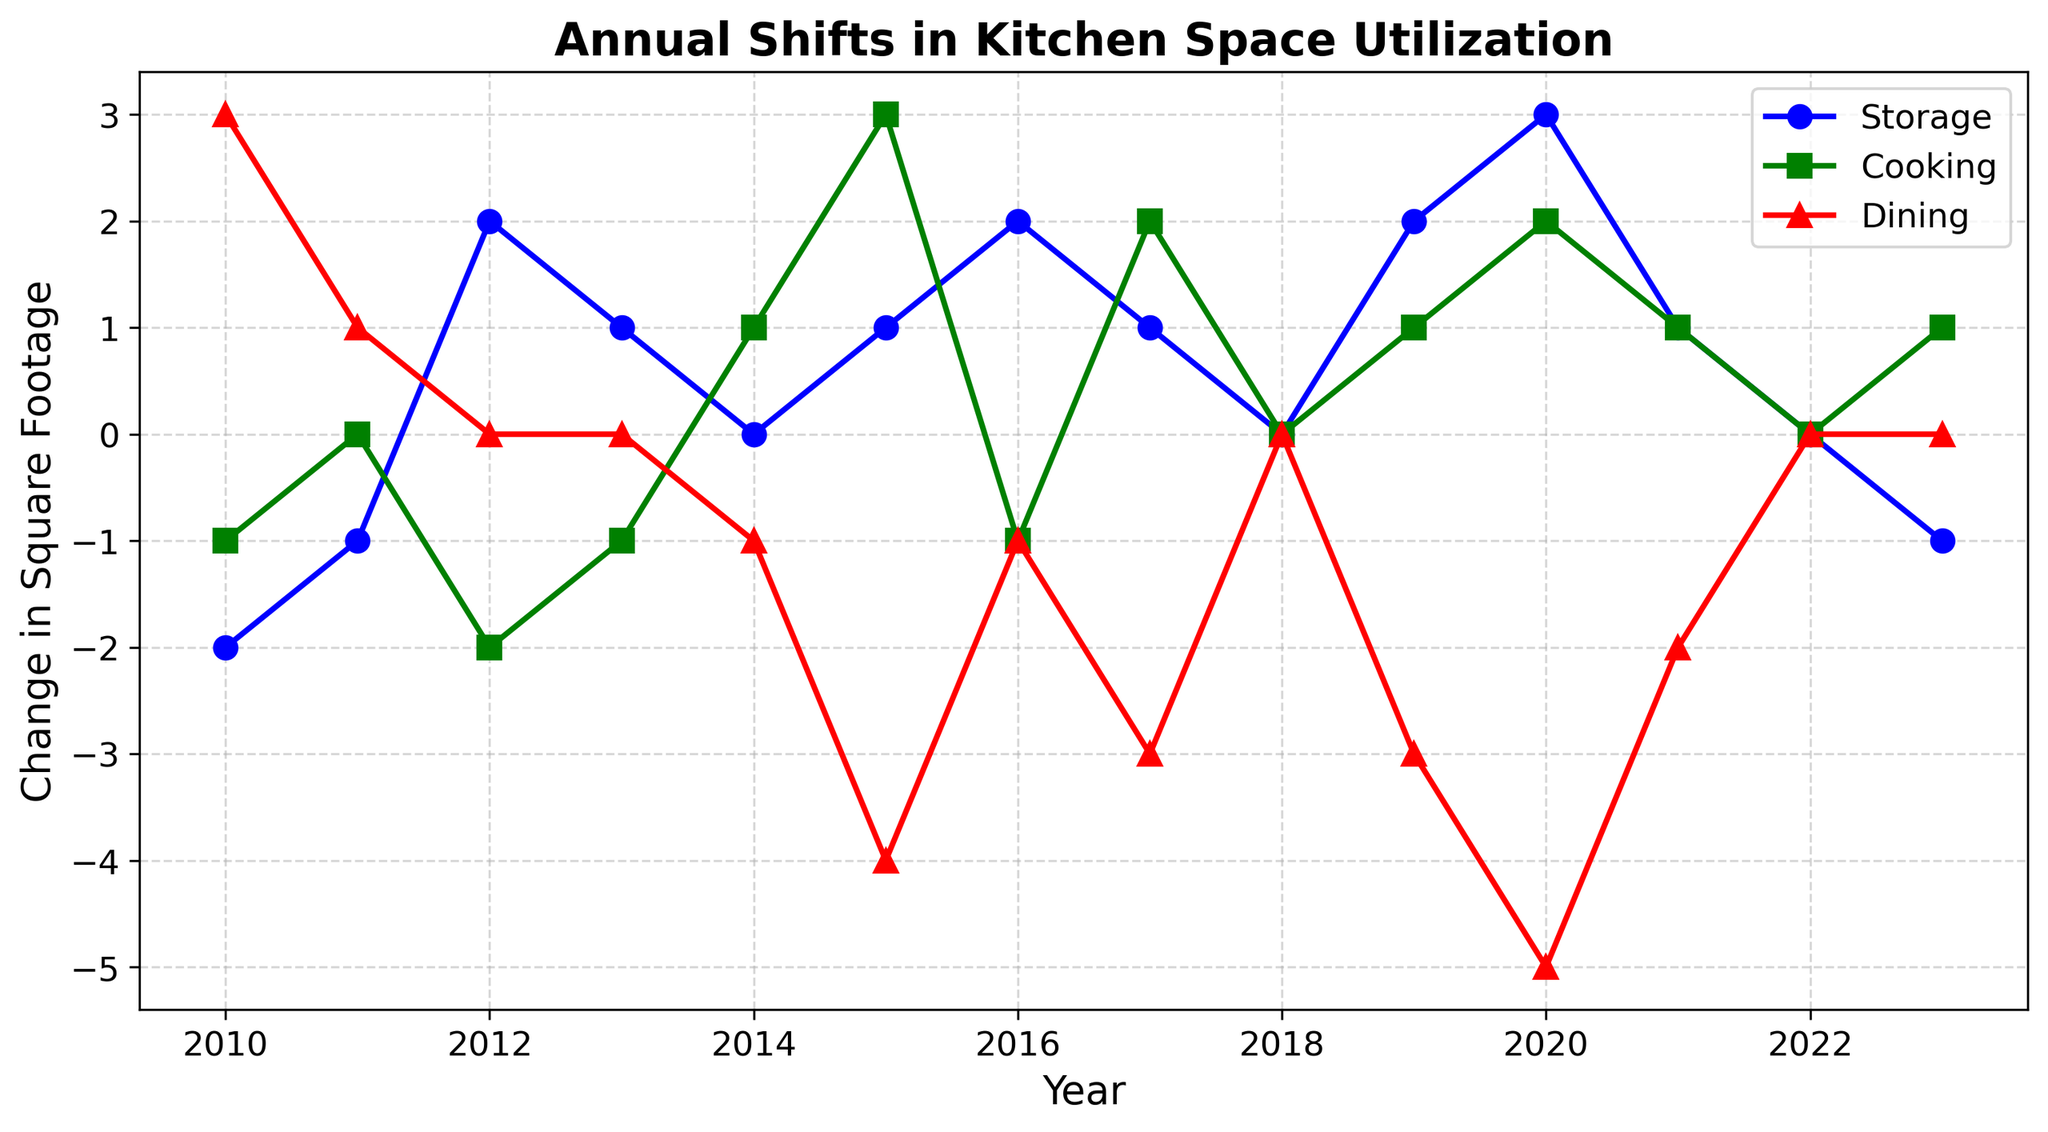How has the proportion of kitchen space used for cooking changed from 2015 to 2017? To determine this, you need to compare the values for cooking space in 2015 and 2017. According to the data, the value in 2015 is 3, and in 2017, it is 2. This means there is a decrease of 1 square foot.
Answer: Decreased by 1 sqft Which area saw the most significant positive change in 2020? To identify which area had the most significant positive change in 2020, compare the values of storage, cooking, and dining for that year. The values are 3 for storage, 2 for cooking, and -5 for dining. The storage area has the highest positive change of 3.
Answer: Storage What is the total change in square footage for the dining area from 2014 to 2016? To find the total change in square footage for the dining area, sum the values from 2014 to 2016. The values are -1 (2014), -4 (2015), and -1 (2016). Summing these gives -1 + (-4) + (-1) = -6.
Answer: -6 sqft Among storage, cooking, and dining areas, which one stayed neutral (no change) the most over the years? To determine which area had no change (i.e., 0 change in square footage), look for zeros in the dataset for storage, cooking, and dining areas. Storage has zeros in 2014 and 2018, cooking has zeros in 2011, 2018, and 2022, while dining has zeros in 2012, 2013, 2018, 2022, and 2023. Dining stayed neutral (0 change) the most.
Answer: Dining How did storage space utilization change from 2010 to 2023? Compare the storage space values from 2010 and 2023. In 2010, the value is -2, and in 2023, it is -1. The change is -1 - (-2) = 1, showing an increase of 1 square foot.
Answer: Increased by 1 sqft What is the trend in cooking space utilization from 2018 to 2020? Review the values for cooking space from 2018, 2019, and 2020, which are 0, 1, and 2, respectively. This shows an increasing trend.
Answer: Increasing Between 2016 and 2021, which area experienced the greatest reduction in square footage? To determine the greatest reduction, calculate the difference for each area between 2016 and 2021. Storage changes from 2 to 1 (decrease by 1), cooking changes from -1 to 1 (increase by 2), and dining changes from -1 to -2 (decrease by 1). All areas decreased or remained the same, but the most significant reduction was in the dining area from -1 to -2.
Answer: Dining In which year did all three areas experience no change in square footage compared to the previous year? This requires identifying a year where storage, cooking, and dining all have zero values. According to the data, this occurs in 2018 and 2022.
Answer: 2018 and 2022 What is the average change in square footage for cooking space from 2010 to 2023? To find the average change, first sum the changes for cooking space across all years: -1, 0, -2, -1, 1, 3, -1, 2, 0, 1, 2, 1, 0, 1 = 6. The average is 6 / 14 = 0.43 (approx).
Answer: 0.43 sqft What was the net change in dining space from 2012 to 2013? The dining space value in 2012 is 0 and in 2013 is 0. Therefore, the net change is 0 - 0 = 0.
Answer: 0 